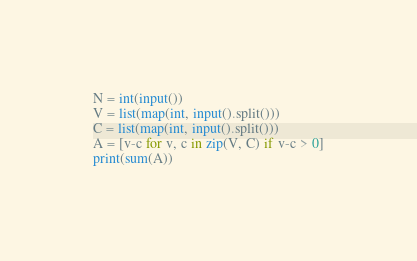Convert code to text. <code><loc_0><loc_0><loc_500><loc_500><_Python_>N = int(input())
V = list(map(int, input().split()))
C = list(map(int, input().split()))
A = [v-c for v, c in zip(V, C) if v-c > 0]
print(sum(A))</code> 